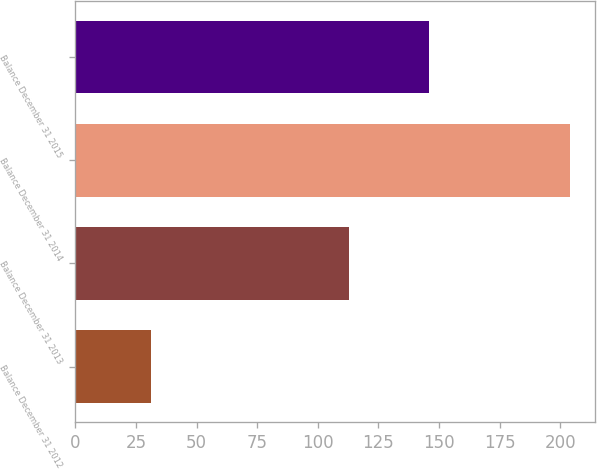Convert chart. <chart><loc_0><loc_0><loc_500><loc_500><bar_chart><fcel>Balance December 31 2012<fcel>Balance December 31 2013<fcel>Balance December 31 2014<fcel>Balance December 31 2015<nl><fcel>31<fcel>113<fcel>204<fcel>146<nl></chart> 